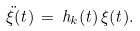<formula> <loc_0><loc_0><loc_500><loc_500>\ddot { \xi } ( t ) \, = \, h _ { k } ( t ) \, \xi ( t ) .</formula> 